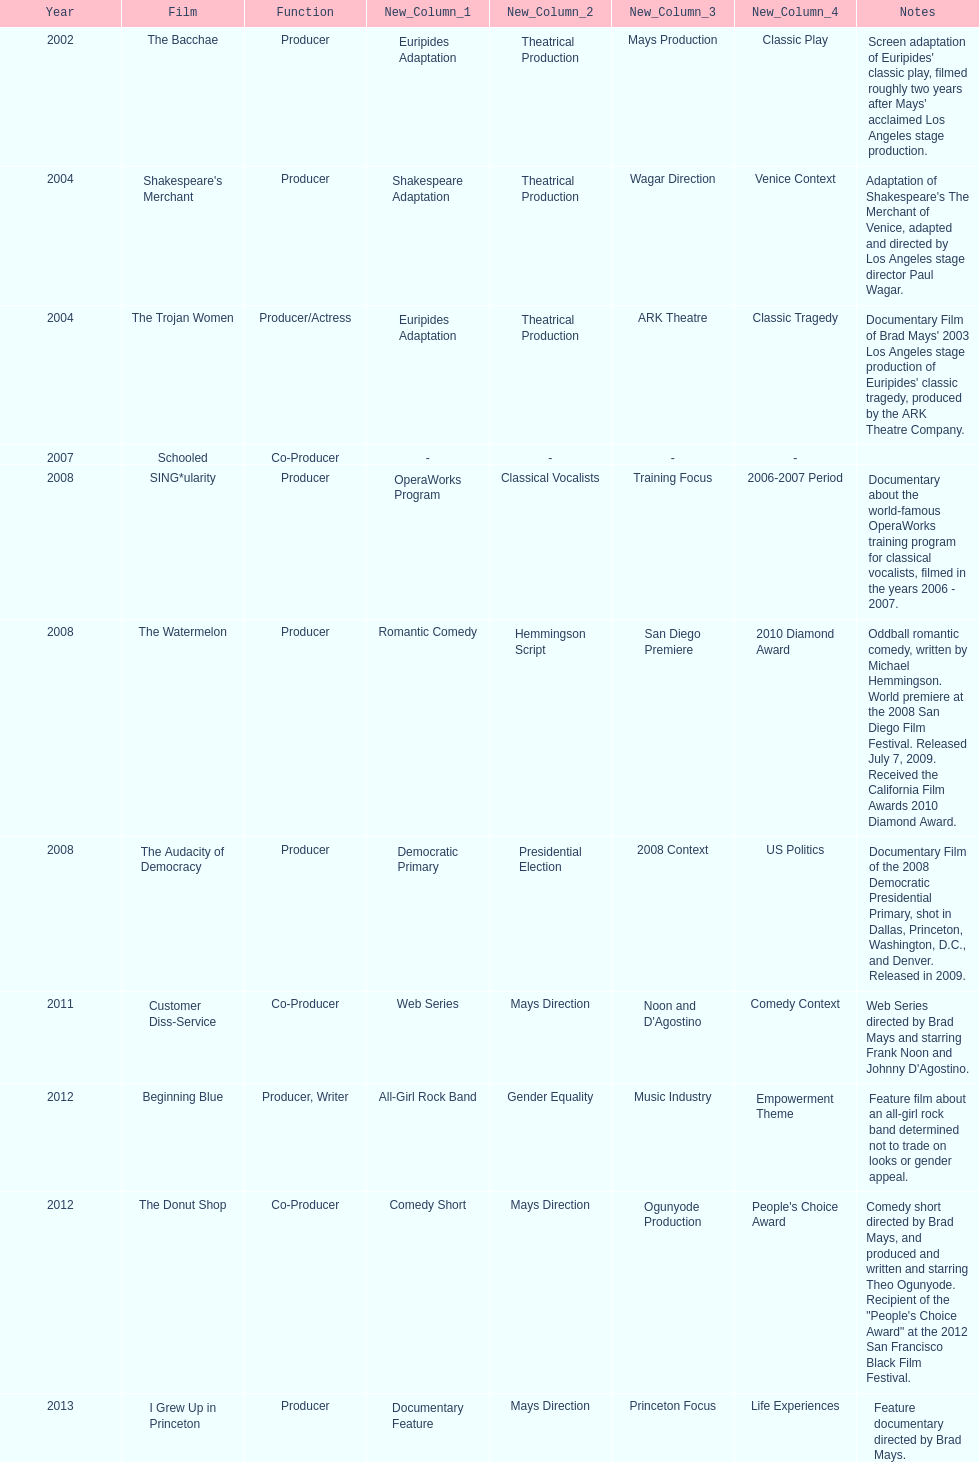How long was the film schooled out before beginning blue? 5 years. 